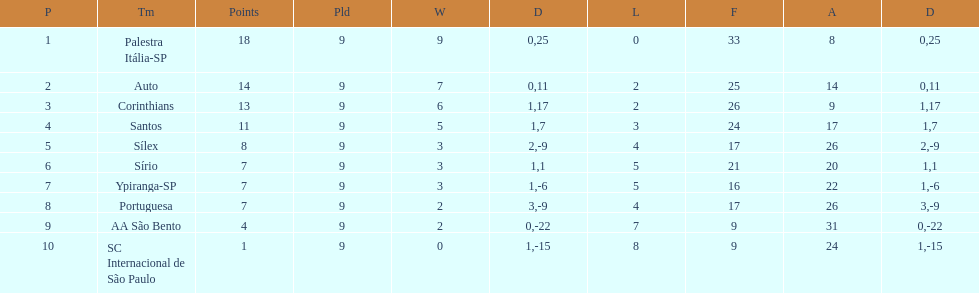Which team was the only team that was undefeated? Palestra Itália-SP. 